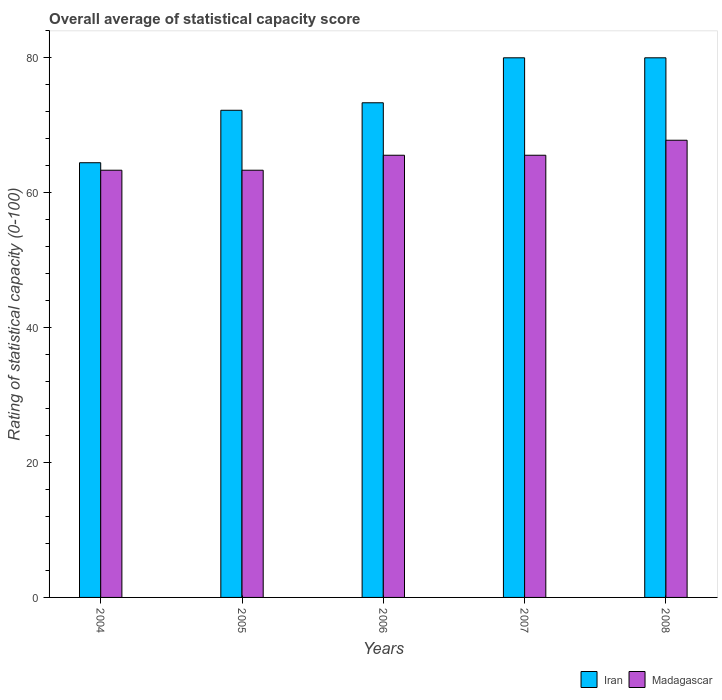How many different coloured bars are there?
Your answer should be very brief. 2. How many groups of bars are there?
Your answer should be compact. 5. Are the number of bars per tick equal to the number of legend labels?
Give a very brief answer. Yes. How many bars are there on the 4th tick from the left?
Your response must be concise. 2. How many bars are there on the 4th tick from the right?
Provide a short and direct response. 2. What is the label of the 4th group of bars from the left?
Make the answer very short. 2007. What is the rating of statistical capacity in Iran in 2004?
Keep it short and to the point. 64.44. Across all years, what is the maximum rating of statistical capacity in Iran?
Give a very brief answer. 80. Across all years, what is the minimum rating of statistical capacity in Iran?
Your answer should be compact. 64.44. In which year was the rating of statistical capacity in Madagascar maximum?
Provide a short and direct response. 2008. In which year was the rating of statistical capacity in Madagascar minimum?
Provide a succinct answer. 2004. What is the total rating of statistical capacity in Madagascar in the graph?
Offer a very short reply. 325.56. What is the difference between the rating of statistical capacity in Madagascar in 2005 and that in 2008?
Keep it short and to the point. -4.44. What is the difference between the rating of statistical capacity in Madagascar in 2006 and the rating of statistical capacity in Iran in 2004?
Your answer should be very brief. 1.11. What is the average rating of statistical capacity in Iran per year?
Your answer should be very brief. 74. In the year 2007, what is the difference between the rating of statistical capacity in Madagascar and rating of statistical capacity in Iran?
Keep it short and to the point. -14.44. What is the ratio of the rating of statistical capacity in Iran in 2004 to that in 2007?
Offer a very short reply. 0.81. What is the difference between the highest and the second highest rating of statistical capacity in Iran?
Ensure brevity in your answer.  0. What is the difference between the highest and the lowest rating of statistical capacity in Madagascar?
Your answer should be very brief. 4.44. What does the 2nd bar from the left in 2007 represents?
Provide a succinct answer. Madagascar. What does the 2nd bar from the right in 2004 represents?
Provide a short and direct response. Iran. How many bars are there?
Provide a succinct answer. 10. Are all the bars in the graph horizontal?
Give a very brief answer. No. What is the difference between two consecutive major ticks on the Y-axis?
Offer a terse response. 20. Are the values on the major ticks of Y-axis written in scientific E-notation?
Make the answer very short. No. How are the legend labels stacked?
Your response must be concise. Horizontal. What is the title of the graph?
Ensure brevity in your answer.  Overall average of statistical capacity score. Does "Macedonia" appear as one of the legend labels in the graph?
Give a very brief answer. No. What is the label or title of the X-axis?
Provide a short and direct response. Years. What is the label or title of the Y-axis?
Offer a very short reply. Rating of statistical capacity (0-100). What is the Rating of statistical capacity (0-100) of Iran in 2004?
Offer a terse response. 64.44. What is the Rating of statistical capacity (0-100) of Madagascar in 2004?
Provide a succinct answer. 63.33. What is the Rating of statistical capacity (0-100) in Iran in 2005?
Your answer should be compact. 72.22. What is the Rating of statistical capacity (0-100) in Madagascar in 2005?
Make the answer very short. 63.33. What is the Rating of statistical capacity (0-100) of Iran in 2006?
Your response must be concise. 73.33. What is the Rating of statistical capacity (0-100) of Madagascar in 2006?
Make the answer very short. 65.56. What is the Rating of statistical capacity (0-100) of Iran in 2007?
Give a very brief answer. 80. What is the Rating of statistical capacity (0-100) in Madagascar in 2007?
Provide a short and direct response. 65.56. What is the Rating of statistical capacity (0-100) in Madagascar in 2008?
Ensure brevity in your answer.  67.78. Across all years, what is the maximum Rating of statistical capacity (0-100) of Iran?
Your response must be concise. 80. Across all years, what is the maximum Rating of statistical capacity (0-100) of Madagascar?
Give a very brief answer. 67.78. Across all years, what is the minimum Rating of statistical capacity (0-100) of Iran?
Your answer should be very brief. 64.44. Across all years, what is the minimum Rating of statistical capacity (0-100) in Madagascar?
Provide a short and direct response. 63.33. What is the total Rating of statistical capacity (0-100) of Iran in the graph?
Your response must be concise. 370. What is the total Rating of statistical capacity (0-100) in Madagascar in the graph?
Offer a very short reply. 325.56. What is the difference between the Rating of statistical capacity (0-100) in Iran in 2004 and that in 2005?
Your response must be concise. -7.78. What is the difference between the Rating of statistical capacity (0-100) of Madagascar in 2004 and that in 2005?
Provide a succinct answer. 0. What is the difference between the Rating of statistical capacity (0-100) in Iran in 2004 and that in 2006?
Keep it short and to the point. -8.89. What is the difference between the Rating of statistical capacity (0-100) of Madagascar in 2004 and that in 2006?
Your response must be concise. -2.22. What is the difference between the Rating of statistical capacity (0-100) in Iran in 2004 and that in 2007?
Provide a succinct answer. -15.56. What is the difference between the Rating of statistical capacity (0-100) in Madagascar in 2004 and that in 2007?
Keep it short and to the point. -2.22. What is the difference between the Rating of statistical capacity (0-100) of Iran in 2004 and that in 2008?
Offer a very short reply. -15.56. What is the difference between the Rating of statistical capacity (0-100) of Madagascar in 2004 and that in 2008?
Ensure brevity in your answer.  -4.44. What is the difference between the Rating of statistical capacity (0-100) of Iran in 2005 and that in 2006?
Provide a short and direct response. -1.11. What is the difference between the Rating of statistical capacity (0-100) in Madagascar in 2005 and that in 2006?
Keep it short and to the point. -2.22. What is the difference between the Rating of statistical capacity (0-100) of Iran in 2005 and that in 2007?
Your response must be concise. -7.78. What is the difference between the Rating of statistical capacity (0-100) of Madagascar in 2005 and that in 2007?
Your answer should be compact. -2.22. What is the difference between the Rating of statistical capacity (0-100) in Iran in 2005 and that in 2008?
Make the answer very short. -7.78. What is the difference between the Rating of statistical capacity (0-100) of Madagascar in 2005 and that in 2008?
Your answer should be compact. -4.44. What is the difference between the Rating of statistical capacity (0-100) of Iran in 2006 and that in 2007?
Make the answer very short. -6.67. What is the difference between the Rating of statistical capacity (0-100) of Iran in 2006 and that in 2008?
Ensure brevity in your answer.  -6.67. What is the difference between the Rating of statistical capacity (0-100) in Madagascar in 2006 and that in 2008?
Your answer should be very brief. -2.22. What is the difference between the Rating of statistical capacity (0-100) of Madagascar in 2007 and that in 2008?
Your response must be concise. -2.22. What is the difference between the Rating of statistical capacity (0-100) of Iran in 2004 and the Rating of statistical capacity (0-100) of Madagascar in 2005?
Keep it short and to the point. 1.11. What is the difference between the Rating of statistical capacity (0-100) of Iran in 2004 and the Rating of statistical capacity (0-100) of Madagascar in 2006?
Ensure brevity in your answer.  -1.11. What is the difference between the Rating of statistical capacity (0-100) in Iran in 2004 and the Rating of statistical capacity (0-100) in Madagascar in 2007?
Your answer should be very brief. -1.11. What is the difference between the Rating of statistical capacity (0-100) in Iran in 2004 and the Rating of statistical capacity (0-100) in Madagascar in 2008?
Give a very brief answer. -3.33. What is the difference between the Rating of statistical capacity (0-100) in Iran in 2005 and the Rating of statistical capacity (0-100) in Madagascar in 2006?
Give a very brief answer. 6.67. What is the difference between the Rating of statistical capacity (0-100) of Iran in 2005 and the Rating of statistical capacity (0-100) of Madagascar in 2008?
Your answer should be very brief. 4.44. What is the difference between the Rating of statistical capacity (0-100) of Iran in 2006 and the Rating of statistical capacity (0-100) of Madagascar in 2007?
Provide a short and direct response. 7.78. What is the difference between the Rating of statistical capacity (0-100) of Iran in 2006 and the Rating of statistical capacity (0-100) of Madagascar in 2008?
Keep it short and to the point. 5.56. What is the difference between the Rating of statistical capacity (0-100) in Iran in 2007 and the Rating of statistical capacity (0-100) in Madagascar in 2008?
Ensure brevity in your answer.  12.22. What is the average Rating of statistical capacity (0-100) in Iran per year?
Keep it short and to the point. 74. What is the average Rating of statistical capacity (0-100) in Madagascar per year?
Your answer should be very brief. 65.11. In the year 2004, what is the difference between the Rating of statistical capacity (0-100) in Iran and Rating of statistical capacity (0-100) in Madagascar?
Your answer should be very brief. 1.11. In the year 2005, what is the difference between the Rating of statistical capacity (0-100) in Iran and Rating of statistical capacity (0-100) in Madagascar?
Make the answer very short. 8.89. In the year 2006, what is the difference between the Rating of statistical capacity (0-100) of Iran and Rating of statistical capacity (0-100) of Madagascar?
Offer a very short reply. 7.78. In the year 2007, what is the difference between the Rating of statistical capacity (0-100) in Iran and Rating of statistical capacity (0-100) in Madagascar?
Ensure brevity in your answer.  14.44. In the year 2008, what is the difference between the Rating of statistical capacity (0-100) of Iran and Rating of statistical capacity (0-100) of Madagascar?
Your response must be concise. 12.22. What is the ratio of the Rating of statistical capacity (0-100) of Iran in 2004 to that in 2005?
Offer a very short reply. 0.89. What is the ratio of the Rating of statistical capacity (0-100) in Iran in 2004 to that in 2006?
Your answer should be compact. 0.88. What is the ratio of the Rating of statistical capacity (0-100) of Madagascar in 2004 to that in 2006?
Your answer should be very brief. 0.97. What is the ratio of the Rating of statistical capacity (0-100) in Iran in 2004 to that in 2007?
Offer a very short reply. 0.81. What is the ratio of the Rating of statistical capacity (0-100) in Madagascar in 2004 to that in 2007?
Give a very brief answer. 0.97. What is the ratio of the Rating of statistical capacity (0-100) of Iran in 2004 to that in 2008?
Your response must be concise. 0.81. What is the ratio of the Rating of statistical capacity (0-100) in Madagascar in 2004 to that in 2008?
Give a very brief answer. 0.93. What is the ratio of the Rating of statistical capacity (0-100) in Madagascar in 2005 to that in 2006?
Give a very brief answer. 0.97. What is the ratio of the Rating of statistical capacity (0-100) of Iran in 2005 to that in 2007?
Keep it short and to the point. 0.9. What is the ratio of the Rating of statistical capacity (0-100) in Madagascar in 2005 to that in 2007?
Your answer should be very brief. 0.97. What is the ratio of the Rating of statistical capacity (0-100) in Iran in 2005 to that in 2008?
Give a very brief answer. 0.9. What is the ratio of the Rating of statistical capacity (0-100) of Madagascar in 2005 to that in 2008?
Give a very brief answer. 0.93. What is the ratio of the Rating of statistical capacity (0-100) of Iran in 2006 to that in 2007?
Provide a short and direct response. 0.92. What is the ratio of the Rating of statistical capacity (0-100) of Iran in 2006 to that in 2008?
Provide a succinct answer. 0.92. What is the ratio of the Rating of statistical capacity (0-100) in Madagascar in 2006 to that in 2008?
Your answer should be compact. 0.97. What is the ratio of the Rating of statistical capacity (0-100) of Iran in 2007 to that in 2008?
Make the answer very short. 1. What is the ratio of the Rating of statistical capacity (0-100) of Madagascar in 2007 to that in 2008?
Your answer should be compact. 0.97. What is the difference between the highest and the second highest Rating of statistical capacity (0-100) in Madagascar?
Provide a short and direct response. 2.22. What is the difference between the highest and the lowest Rating of statistical capacity (0-100) in Iran?
Offer a very short reply. 15.56. What is the difference between the highest and the lowest Rating of statistical capacity (0-100) of Madagascar?
Offer a very short reply. 4.44. 